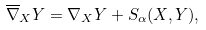Convert formula to latex. <formula><loc_0><loc_0><loc_500><loc_500>\overline { \nabla } _ { X } Y = \nabla _ { X } Y + S _ { \alpha } ( X , Y ) ,</formula> 